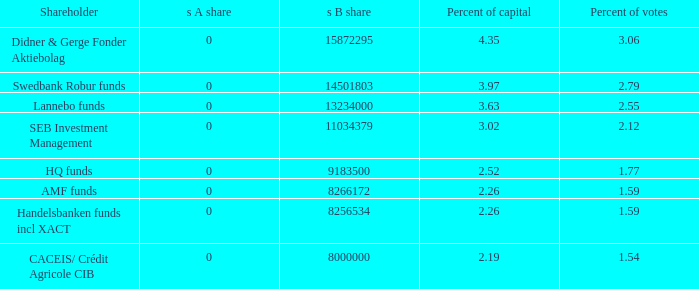63 percent of ownership? Lannebo funds. 